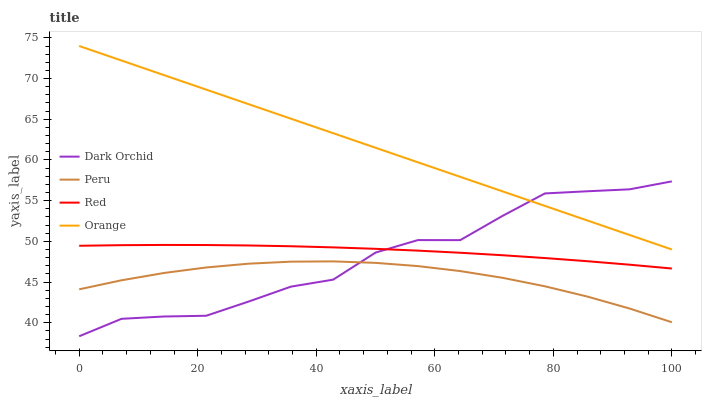Does Red have the minimum area under the curve?
Answer yes or no. No. Does Red have the maximum area under the curve?
Answer yes or no. No. Is Red the smoothest?
Answer yes or no. No. Is Red the roughest?
Answer yes or no. No. Does Red have the lowest value?
Answer yes or no. No. Does Red have the highest value?
Answer yes or no. No. Is Peru less than Red?
Answer yes or no. Yes. Is Red greater than Peru?
Answer yes or no. Yes. Does Peru intersect Red?
Answer yes or no. No. 